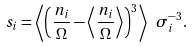<formula> <loc_0><loc_0><loc_500><loc_500>s _ { i } = \left \langle \left ( \frac { n _ { i } } { \Omega } - \left \langle \frac { n _ { i } } { \Omega } \right \rangle \right ) ^ { 3 } \right \rangle \ \sigma _ { i } ^ { - 3 } .</formula> 